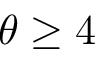<formula> <loc_0><loc_0><loc_500><loc_500>\theta \geq 4</formula> 